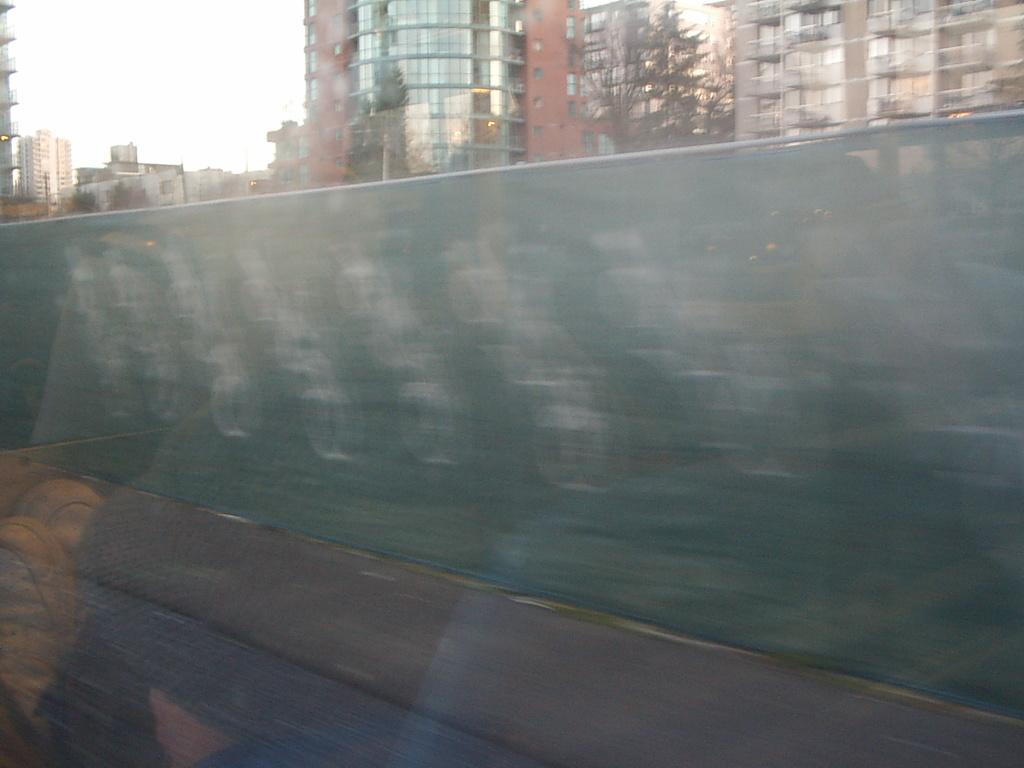What can be seen on the left side of the image? There is a road on the left side of the image. What is located near the road? There is a footpath near the road. What is placed near the footpath? There is a sheet near the footpath. What can be seen in the background of the image? There are trees and buildings with glass windows in the background. What is visible in the sky in the image? The sky is visible in the image. What type of cloud can be seen in the image? There is no cloud visible in the image; only the sky is visible. How does the cough affect the sheet near the footpath in the image? There is no cough present in the image, and therefore no effect on the sheet can be observed. 